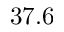<formula> <loc_0><loc_0><loc_500><loc_500>3 7 . 6</formula> 